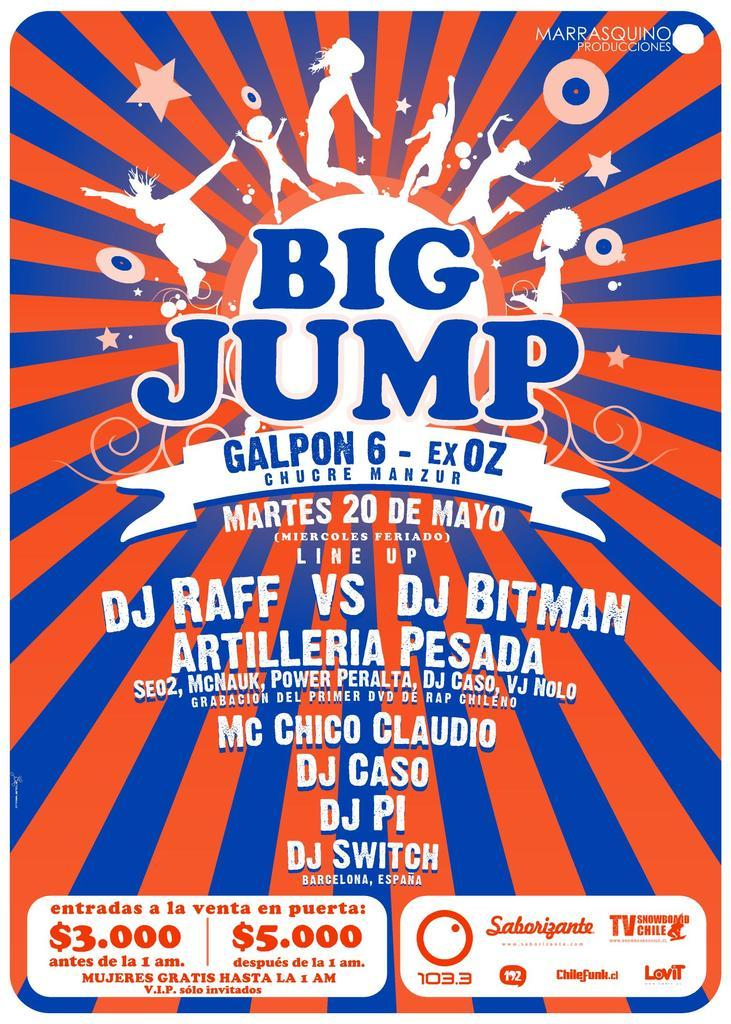<image>
Write a terse but informative summary of the picture. an advertisement for an event that is 3.000 dollars 